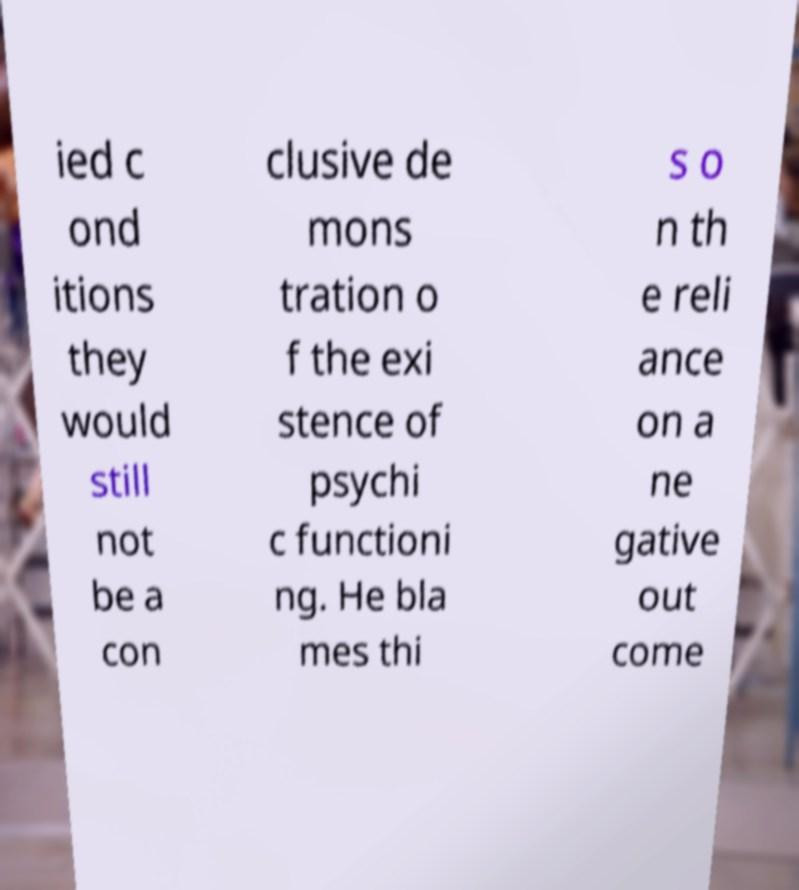Please read and relay the text visible in this image. What does it say? ied c ond itions they would still not be a con clusive de mons tration o f the exi stence of psychi c functioni ng. He bla mes thi s o n th e reli ance on a ne gative out come 